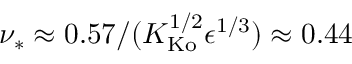Convert formula to latex. <formula><loc_0><loc_0><loc_500><loc_500>\nu _ { * } \approx 0 . 5 7 / ( K _ { K o } ^ { 1 / 2 } \epsilon ^ { 1 / 3 } ) \approx 0 . 4 4</formula> 